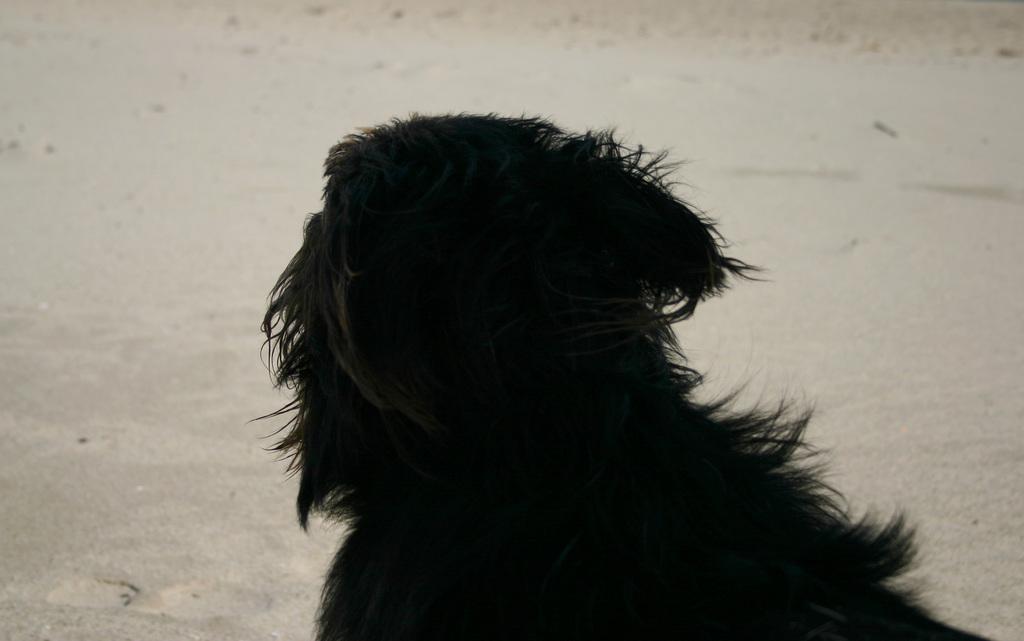How would you summarize this image in a sentence or two? In this image there is a black color animal towards the bottom of the image, at the background of the image there is ground. 